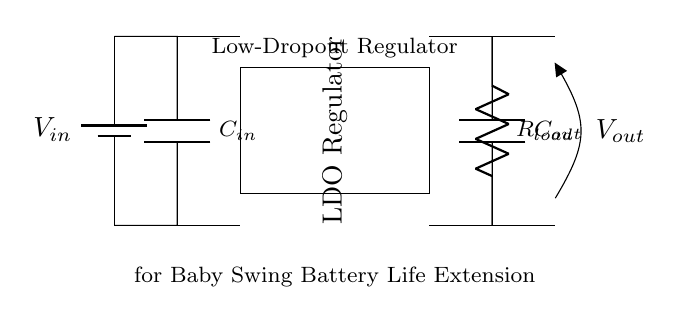What is the input voltage in this circuit? The input voltage is denoted by V_in, which is shown as coming from the battery component labeled at the top left of the diagram.
Answer: V_in What type of regulator is used in this circuit? The circuit specifically shows a Low-Dropout Regulator (LDO), which is labeled in the rectangular block in the middle of the circuit diagram.
Answer: Low-Dropout Regulator How many capacitors are present in the circuit? There are two capacitors indicated by the symbols labeled as C_in and C_out in the circuit diagram.
Answer: 2 What component is used to manage the output load? The load is managed by a resistor, represented in the diagram as R_load, which connects to the output capacitor.
Answer: Resistor Why is an LDO regulator chosen for this circuit? An LDO regulator is chosen because it provides a low voltage drop between the input and output, which helps extend battery life, especially useful in portable applications like a baby swing.
Answer: To extend battery life What is the purpose of the output capacitor? The output capacitor (C_out) smooths the voltage output and helps stabilize the load conditions, improving the performance of the regulator by reducing voltage ripple.
Answer: Stabilizes voltage What does the load resistor represent in this circuit? The load resistor represents the device or component drawing power from the regulator, simulating the load that the baby swing will place on the system.
Answer: Load for baby swing 